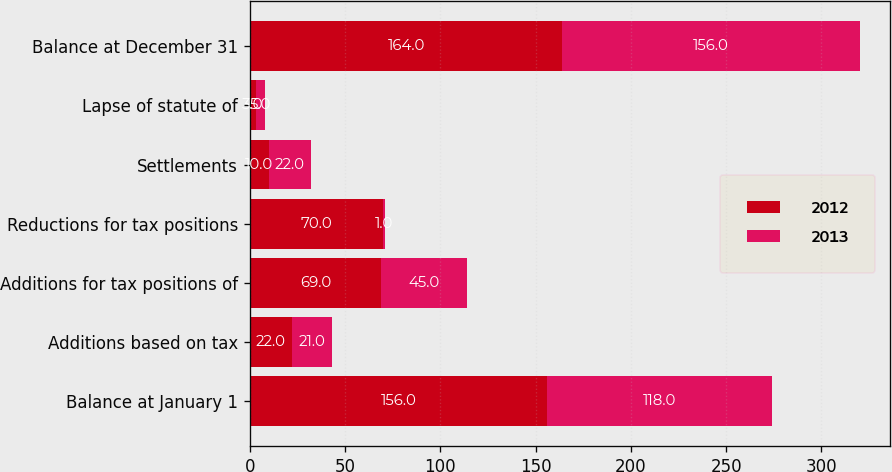Convert chart to OTSL. <chart><loc_0><loc_0><loc_500><loc_500><stacked_bar_chart><ecel><fcel>Balance at January 1<fcel>Additions based on tax<fcel>Additions for tax positions of<fcel>Reductions for tax positions<fcel>Settlements<fcel>Lapse of statute of<fcel>Balance at December 31<nl><fcel>2012<fcel>156<fcel>22<fcel>69<fcel>70<fcel>10<fcel>3<fcel>164<nl><fcel>2013<fcel>118<fcel>21<fcel>45<fcel>1<fcel>22<fcel>5<fcel>156<nl></chart> 